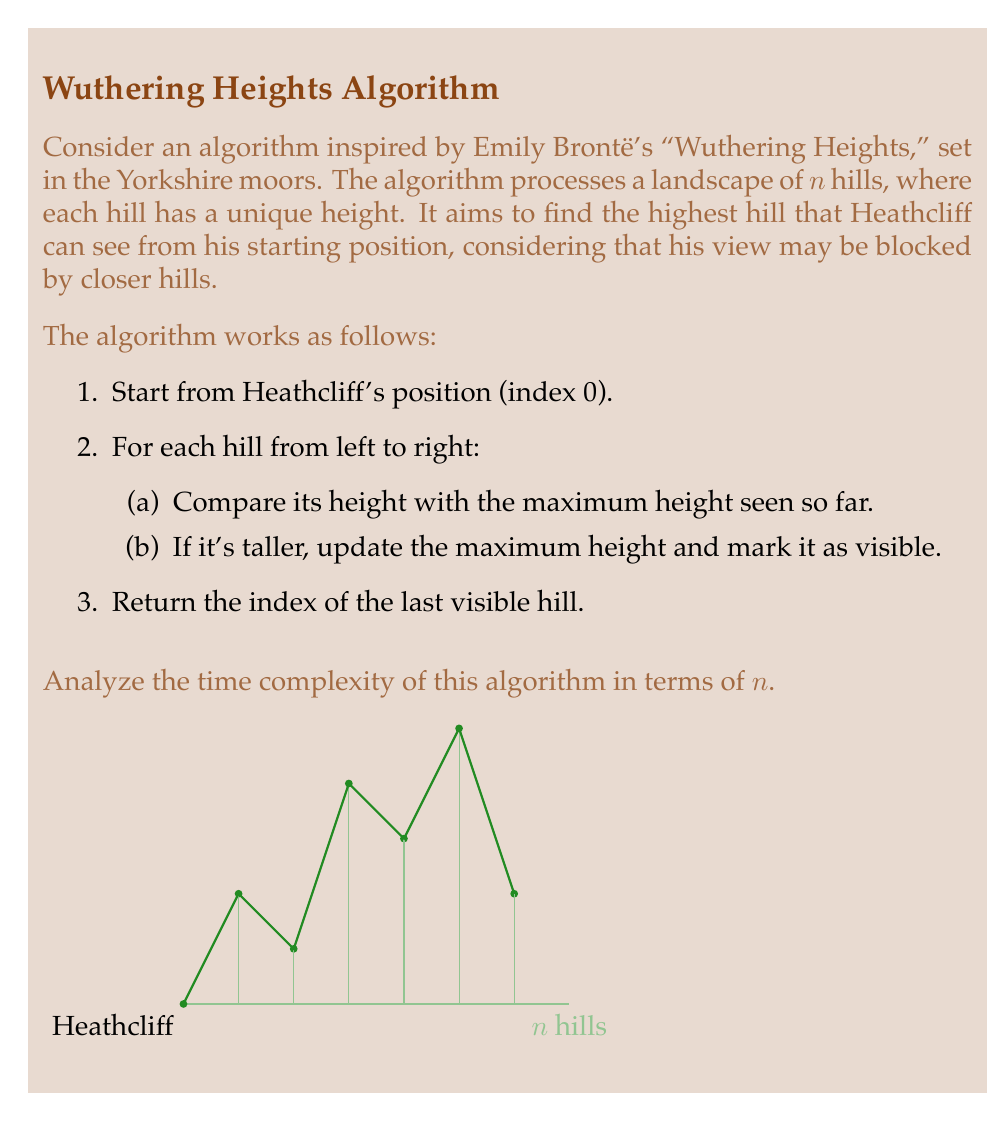Can you solve this math problem? To analyze the time complexity of this algorithm, let's break it down step by step:

1. Initialization:
   - Setting Heathcliff's starting position and initializing variables takes constant time, $O(1)$.

2. Main loop:
   - The algorithm iterates through all $n$ hills once, from left to right.
   - For each hill, it performs two constant-time operations:
     a. Comparing the hill's height with the maximum height seen so far.
     b. Potentially updating the maximum height and marking the hill as visible.
   - These operations inside the loop take constant time, $O(1)$.
   - The loop runs $n$ times, once for each hill.

3. Return statement:
   - Returning the index of the last visible hill takes constant time, $O(1)$.

Now, let's combine these steps:
$$T(n) = O(1) + n \cdot O(1) + O(1)$$

Simplifying:
$$T(n) = O(n) + O(1) = O(n)$$

The dominant term is $O(n)$, which comes from the main loop iterating through all hills once.

This algorithm has a linear time complexity because it processes each hill exactly once, and the operations performed for each hill are constant-time. The time taken grows linearly with the number of hills in the landscape.
Answer: $O(n)$ 